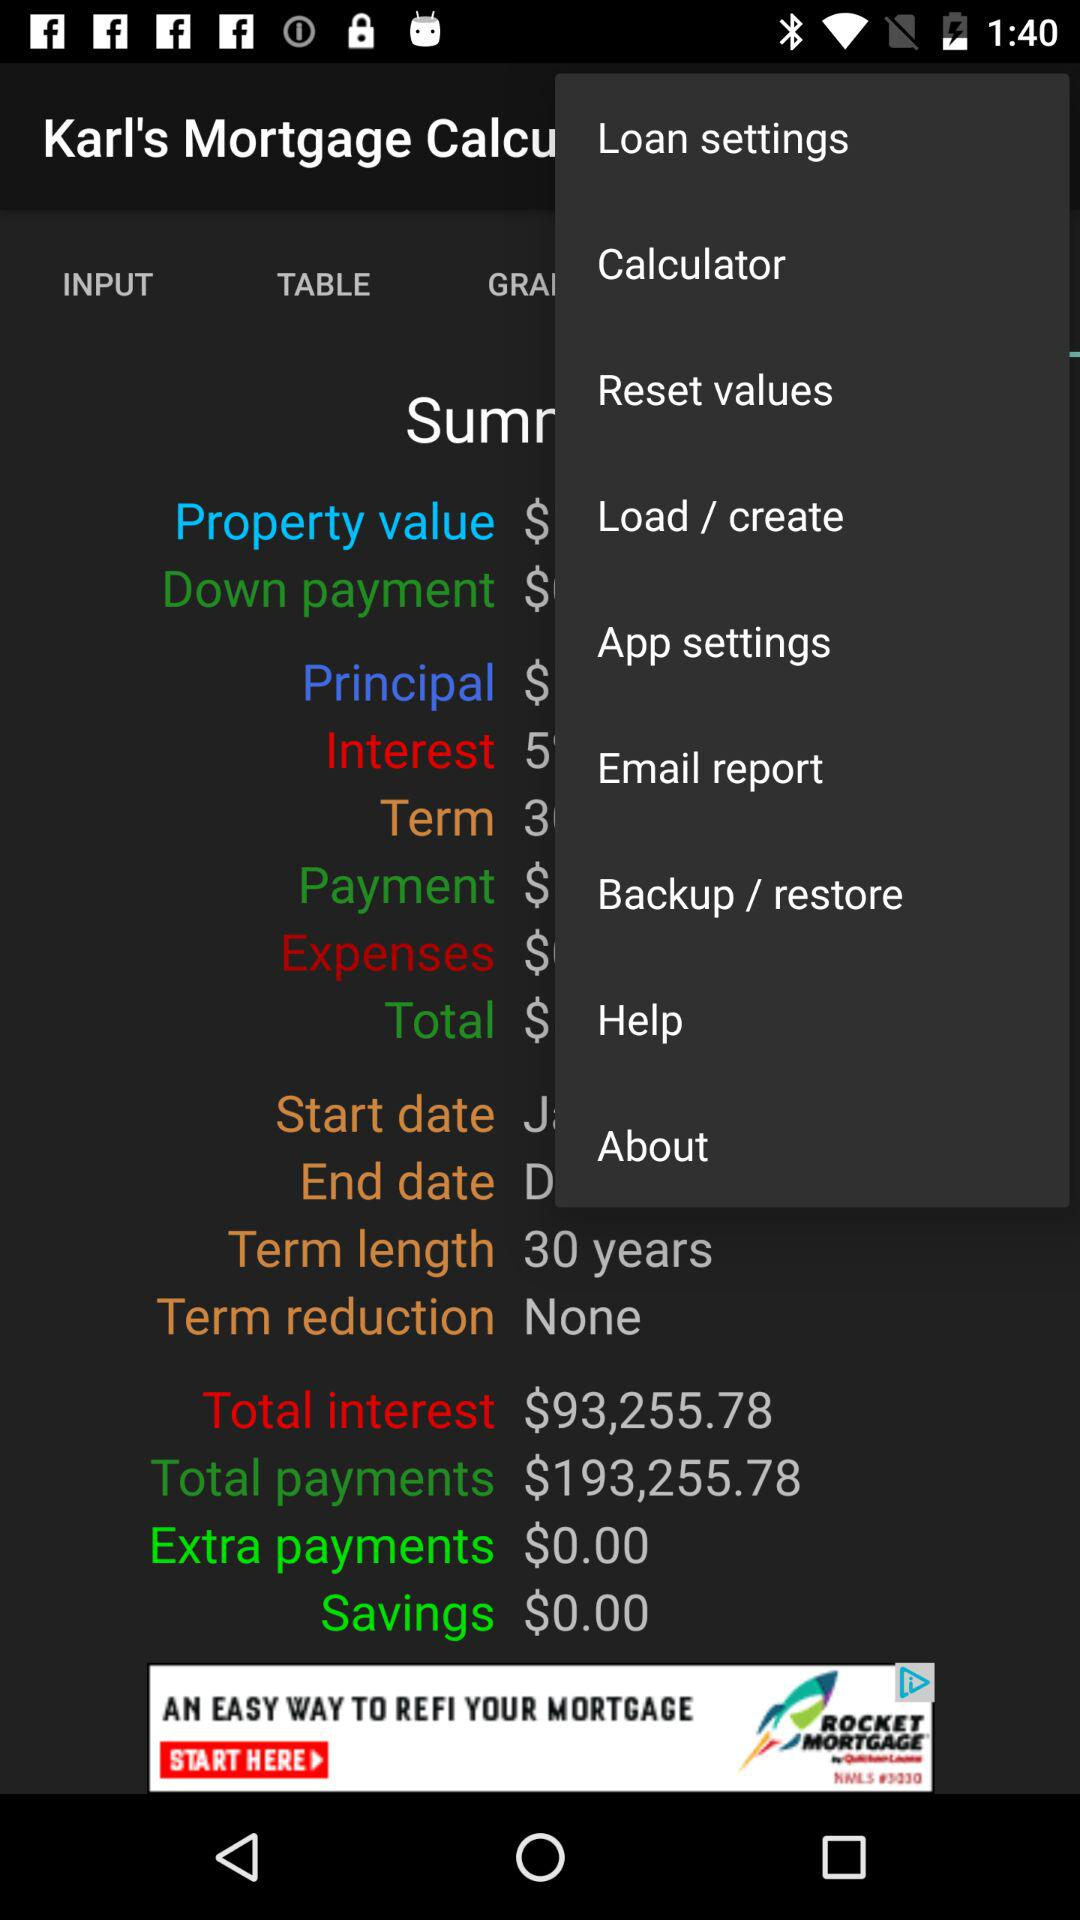What is the term length? The term length is 30 years. 